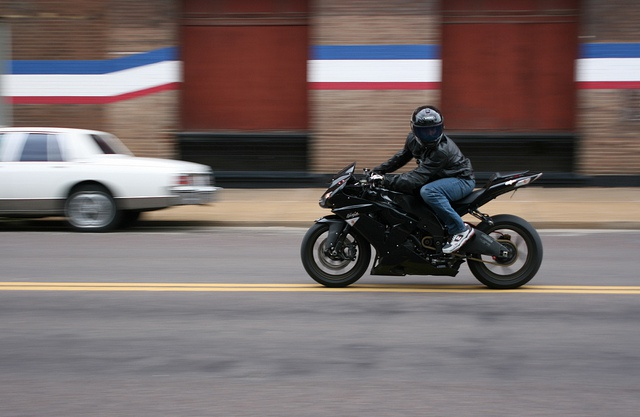Describe the objects in this image and their specific colors. I can see motorcycle in maroon, black, gray, darkgray, and purple tones, car in maroon, lightgray, gray, darkgray, and black tones, and people in maroon, black, gray, and blue tones in this image. 